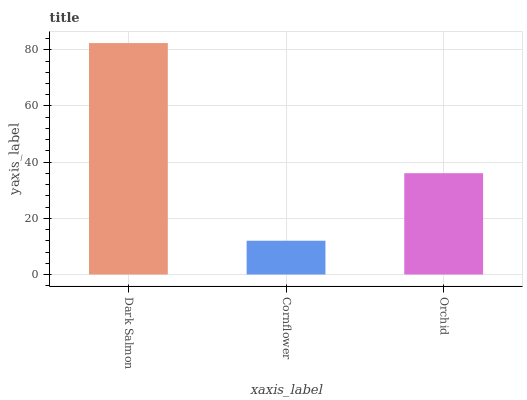Is Cornflower the minimum?
Answer yes or no. Yes. Is Dark Salmon the maximum?
Answer yes or no. Yes. Is Orchid the minimum?
Answer yes or no. No. Is Orchid the maximum?
Answer yes or no. No. Is Orchid greater than Cornflower?
Answer yes or no. Yes. Is Cornflower less than Orchid?
Answer yes or no. Yes. Is Cornflower greater than Orchid?
Answer yes or no. No. Is Orchid less than Cornflower?
Answer yes or no. No. Is Orchid the high median?
Answer yes or no. Yes. Is Orchid the low median?
Answer yes or no. Yes. Is Dark Salmon the high median?
Answer yes or no. No. Is Dark Salmon the low median?
Answer yes or no. No. 